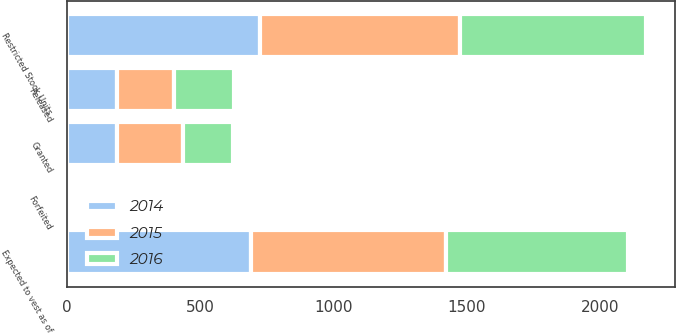Convert chart. <chart><loc_0><loc_0><loc_500><loc_500><stacked_bar_chart><ecel><fcel>Restricted Stock Units<fcel>Granted<fcel>Released<fcel>Forfeited<fcel>Expected to vest as of<nl><fcel>2016<fcel>695<fcel>187<fcel>226<fcel>16<fcel>682<nl><fcel>2015<fcel>750<fcel>248<fcel>212<fcel>11<fcel>731<nl><fcel>2014<fcel>725<fcel>189<fcel>189<fcel>8<fcel>691<nl></chart> 